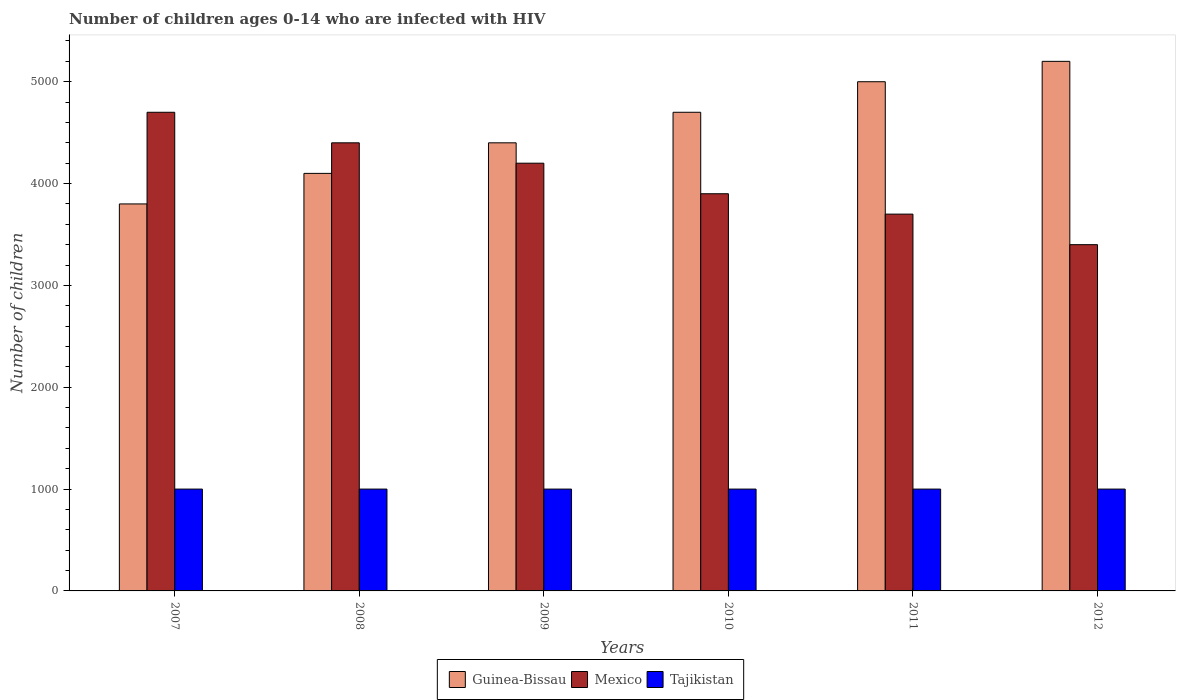How many bars are there on the 1st tick from the left?
Your answer should be compact. 3. How many bars are there on the 3rd tick from the right?
Keep it short and to the point. 3. What is the label of the 3rd group of bars from the left?
Your answer should be compact. 2009. In how many cases, is the number of bars for a given year not equal to the number of legend labels?
Offer a terse response. 0. What is the number of HIV infected children in Tajikistan in 2012?
Make the answer very short. 1000. Across all years, what is the maximum number of HIV infected children in Guinea-Bissau?
Your answer should be compact. 5200. Across all years, what is the minimum number of HIV infected children in Guinea-Bissau?
Provide a short and direct response. 3800. What is the total number of HIV infected children in Guinea-Bissau in the graph?
Your response must be concise. 2.72e+04. What is the difference between the number of HIV infected children in Tajikistan in 2007 and the number of HIV infected children in Mexico in 2009?
Your answer should be compact. -3200. What is the average number of HIV infected children in Tajikistan per year?
Offer a very short reply. 1000. In the year 2007, what is the difference between the number of HIV infected children in Mexico and number of HIV infected children in Guinea-Bissau?
Ensure brevity in your answer.  900. In how many years, is the number of HIV infected children in Mexico greater than 3200?
Offer a very short reply. 6. Is the number of HIV infected children in Mexico in 2008 less than that in 2011?
Your response must be concise. No. Is the difference between the number of HIV infected children in Mexico in 2008 and 2012 greater than the difference between the number of HIV infected children in Guinea-Bissau in 2008 and 2012?
Provide a succinct answer. Yes. What is the difference between the highest and the second highest number of HIV infected children in Mexico?
Make the answer very short. 300. What is the difference between the highest and the lowest number of HIV infected children in Mexico?
Give a very brief answer. 1300. In how many years, is the number of HIV infected children in Tajikistan greater than the average number of HIV infected children in Tajikistan taken over all years?
Your response must be concise. 0. What does the 3rd bar from the left in 2011 represents?
Give a very brief answer. Tajikistan. What does the 1st bar from the right in 2008 represents?
Your answer should be very brief. Tajikistan. How many years are there in the graph?
Provide a short and direct response. 6. What is the difference between two consecutive major ticks on the Y-axis?
Ensure brevity in your answer.  1000. Are the values on the major ticks of Y-axis written in scientific E-notation?
Your response must be concise. No. Does the graph contain grids?
Your answer should be compact. No. Where does the legend appear in the graph?
Your answer should be very brief. Bottom center. How many legend labels are there?
Offer a terse response. 3. How are the legend labels stacked?
Make the answer very short. Horizontal. What is the title of the graph?
Give a very brief answer. Number of children ages 0-14 who are infected with HIV. What is the label or title of the Y-axis?
Provide a succinct answer. Number of children. What is the Number of children in Guinea-Bissau in 2007?
Ensure brevity in your answer.  3800. What is the Number of children in Mexico in 2007?
Your answer should be very brief. 4700. What is the Number of children in Tajikistan in 2007?
Provide a short and direct response. 1000. What is the Number of children in Guinea-Bissau in 2008?
Your answer should be very brief. 4100. What is the Number of children in Mexico in 2008?
Offer a very short reply. 4400. What is the Number of children of Guinea-Bissau in 2009?
Your answer should be compact. 4400. What is the Number of children in Mexico in 2009?
Give a very brief answer. 4200. What is the Number of children of Guinea-Bissau in 2010?
Offer a terse response. 4700. What is the Number of children in Mexico in 2010?
Your response must be concise. 3900. What is the Number of children of Tajikistan in 2010?
Give a very brief answer. 1000. What is the Number of children in Mexico in 2011?
Your answer should be very brief. 3700. What is the Number of children of Tajikistan in 2011?
Your answer should be compact. 1000. What is the Number of children of Guinea-Bissau in 2012?
Ensure brevity in your answer.  5200. What is the Number of children of Mexico in 2012?
Offer a very short reply. 3400. What is the Number of children of Tajikistan in 2012?
Offer a very short reply. 1000. Across all years, what is the maximum Number of children in Guinea-Bissau?
Your response must be concise. 5200. Across all years, what is the maximum Number of children in Mexico?
Make the answer very short. 4700. Across all years, what is the minimum Number of children of Guinea-Bissau?
Offer a very short reply. 3800. Across all years, what is the minimum Number of children of Mexico?
Make the answer very short. 3400. What is the total Number of children in Guinea-Bissau in the graph?
Provide a succinct answer. 2.72e+04. What is the total Number of children of Mexico in the graph?
Ensure brevity in your answer.  2.43e+04. What is the total Number of children in Tajikistan in the graph?
Provide a short and direct response. 6000. What is the difference between the Number of children in Guinea-Bissau in 2007 and that in 2008?
Offer a terse response. -300. What is the difference between the Number of children in Mexico in 2007 and that in 2008?
Your response must be concise. 300. What is the difference between the Number of children in Tajikistan in 2007 and that in 2008?
Make the answer very short. 0. What is the difference between the Number of children in Guinea-Bissau in 2007 and that in 2009?
Offer a very short reply. -600. What is the difference between the Number of children of Tajikistan in 2007 and that in 2009?
Your answer should be compact. 0. What is the difference between the Number of children of Guinea-Bissau in 2007 and that in 2010?
Your response must be concise. -900. What is the difference between the Number of children of Mexico in 2007 and that in 2010?
Offer a very short reply. 800. What is the difference between the Number of children in Guinea-Bissau in 2007 and that in 2011?
Your answer should be compact. -1200. What is the difference between the Number of children of Mexico in 2007 and that in 2011?
Provide a succinct answer. 1000. What is the difference between the Number of children of Tajikistan in 2007 and that in 2011?
Provide a succinct answer. 0. What is the difference between the Number of children in Guinea-Bissau in 2007 and that in 2012?
Ensure brevity in your answer.  -1400. What is the difference between the Number of children of Mexico in 2007 and that in 2012?
Your response must be concise. 1300. What is the difference between the Number of children of Guinea-Bissau in 2008 and that in 2009?
Offer a very short reply. -300. What is the difference between the Number of children of Mexico in 2008 and that in 2009?
Offer a terse response. 200. What is the difference between the Number of children of Guinea-Bissau in 2008 and that in 2010?
Offer a terse response. -600. What is the difference between the Number of children in Mexico in 2008 and that in 2010?
Offer a terse response. 500. What is the difference between the Number of children in Guinea-Bissau in 2008 and that in 2011?
Provide a short and direct response. -900. What is the difference between the Number of children of Mexico in 2008 and that in 2011?
Your response must be concise. 700. What is the difference between the Number of children in Tajikistan in 2008 and that in 2011?
Ensure brevity in your answer.  0. What is the difference between the Number of children of Guinea-Bissau in 2008 and that in 2012?
Provide a short and direct response. -1100. What is the difference between the Number of children of Guinea-Bissau in 2009 and that in 2010?
Your answer should be compact. -300. What is the difference between the Number of children of Mexico in 2009 and that in 2010?
Your answer should be very brief. 300. What is the difference between the Number of children in Tajikistan in 2009 and that in 2010?
Keep it short and to the point. 0. What is the difference between the Number of children of Guinea-Bissau in 2009 and that in 2011?
Ensure brevity in your answer.  -600. What is the difference between the Number of children in Mexico in 2009 and that in 2011?
Make the answer very short. 500. What is the difference between the Number of children in Guinea-Bissau in 2009 and that in 2012?
Your response must be concise. -800. What is the difference between the Number of children of Mexico in 2009 and that in 2012?
Your response must be concise. 800. What is the difference between the Number of children of Guinea-Bissau in 2010 and that in 2011?
Give a very brief answer. -300. What is the difference between the Number of children in Tajikistan in 2010 and that in 2011?
Ensure brevity in your answer.  0. What is the difference between the Number of children in Guinea-Bissau in 2010 and that in 2012?
Keep it short and to the point. -500. What is the difference between the Number of children in Mexico in 2010 and that in 2012?
Give a very brief answer. 500. What is the difference between the Number of children in Tajikistan in 2010 and that in 2012?
Ensure brevity in your answer.  0. What is the difference between the Number of children in Guinea-Bissau in 2011 and that in 2012?
Offer a very short reply. -200. What is the difference between the Number of children of Mexico in 2011 and that in 2012?
Your answer should be very brief. 300. What is the difference between the Number of children in Guinea-Bissau in 2007 and the Number of children in Mexico in 2008?
Ensure brevity in your answer.  -600. What is the difference between the Number of children of Guinea-Bissau in 2007 and the Number of children of Tajikistan in 2008?
Ensure brevity in your answer.  2800. What is the difference between the Number of children in Mexico in 2007 and the Number of children in Tajikistan in 2008?
Provide a short and direct response. 3700. What is the difference between the Number of children in Guinea-Bissau in 2007 and the Number of children in Mexico in 2009?
Your response must be concise. -400. What is the difference between the Number of children in Guinea-Bissau in 2007 and the Number of children in Tajikistan in 2009?
Your answer should be compact. 2800. What is the difference between the Number of children of Mexico in 2007 and the Number of children of Tajikistan in 2009?
Your response must be concise. 3700. What is the difference between the Number of children of Guinea-Bissau in 2007 and the Number of children of Mexico in 2010?
Keep it short and to the point. -100. What is the difference between the Number of children of Guinea-Bissau in 2007 and the Number of children of Tajikistan in 2010?
Provide a short and direct response. 2800. What is the difference between the Number of children of Mexico in 2007 and the Number of children of Tajikistan in 2010?
Give a very brief answer. 3700. What is the difference between the Number of children in Guinea-Bissau in 2007 and the Number of children in Tajikistan in 2011?
Offer a very short reply. 2800. What is the difference between the Number of children of Mexico in 2007 and the Number of children of Tajikistan in 2011?
Provide a short and direct response. 3700. What is the difference between the Number of children of Guinea-Bissau in 2007 and the Number of children of Mexico in 2012?
Offer a terse response. 400. What is the difference between the Number of children in Guinea-Bissau in 2007 and the Number of children in Tajikistan in 2012?
Your answer should be very brief. 2800. What is the difference between the Number of children in Mexico in 2007 and the Number of children in Tajikistan in 2012?
Your answer should be very brief. 3700. What is the difference between the Number of children in Guinea-Bissau in 2008 and the Number of children in Mexico in 2009?
Make the answer very short. -100. What is the difference between the Number of children in Guinea-Bissau in 2008 and the Number of children in Tajikistan in 2009?
Your response must be concise. 3100. What is the difference between the Number of children in Mexico in 2008 and the Number of children in Tajikistan in 2009?
Provide a short and direct response. 3400. What is the difference between the Number of children in Guinea-Bissau in 2008 and the Number of children in Mexico in 2010?
Offer a terse response. 200. What is the difference between the Number of children of Guinea-Bissau in 2008 and the Number of children of Tajikistan in 2010?
Make the answer very short. 3100. What is the difference between the Number of children of Mexico in 2008 and the Number of children of Tajikistan in 2010?
Offer a very short reply. 3400. What is the difference between the Number of children in Guinea-Bissau in 2008 and the Number of children in Mexico in 2011?
Ensure brevity in your answer.  400. What is the difference between the Number of children of Guinea-Bissau in 2008 and the Number of children of Tajikistan in 2011?
Your answer should be very brief. 3100. What is the difference between the Number of children of Mexico in 2008 and the Number of children of Tajikistan in 2011?
Offer a terse response. 3400. What is the difference between the Number of children in Guinea-Bissau in 2008 and the Number of children in Mexico in 2012?
Provide a short and direct response. 700. What is the difference between the Number of children in Guinea-Bissau in 2008 and the Number of children in Tajikistan in 2012?
Your response must be concise. 3100. What is the difference between the Number of children in Mexico in 2008 and the Number of children in Tajikistan in 2012?
Provide a succinct answer. 3400. What is the difference between the Number of children of Guinea-Bissau in 2009 and the Number of children of Mexico in 2010?
Provide a short and direct response. 500. What is the difference between the Number of children of Guinea-Bissau in 2009 and the Number of children of Tajikistan in 2010?
Provide a succinct answer. 3400. What is the difference between the Number of children of Mexico in 2009 and the Number of children of Tajikistan in 2010?
Provide a short and direct response. 3200. What is the difference between the Number of children of Guinea-Bissau in 2009 and the Number of children of Mexico in 2011?
Provide a short and direct response. 700. What is the difference between the Number of children in Guinea-Bissau in 2009 and the Number of children in Tajikistan in 2011?
Give a very brief answer. 3400. What is the difference between the Number of children of Mexico in 2009 and the Number of children of Tajikistan in 2011?
Your answer should be very brief. 3200. What is the difference between the Number of children of Guinea-Bissau in 2009 and the Number of children of Mexico in 2012?
Make the answer very short. 1000. What is the difference between the Number of children of Guinea-Bissau in 2009 and the Number of children of Tajikistan in 2012?
Keep it short and to the point. 3400. What is the difference between the Number of children of Mexico in 2009 and the Number of children of Tajikistan in 2012?
Give a very brief answer. 3200. What is the difference between the Number of children of Guinea-Bissau in 2010 and the Number of children of Tajikistan in 2011?
Offer a very short reply. 3700. What is the difference between the Number of children in Mexico in 2010 and the Number of children in Tajikistan in 2011?
Your answer should be compact. 2900. What is the difference between the Number of children of Guinea-Bissau in 2010 and the Number of children of Mexico in 2012?
Offer a very short reply. 1300. What is the difference between the Number of children in Guinea-Bissau in 2010 and the Number of children in Tajikistan in 2012?
Give a very brief answer. 3700. What is the difference between the Number of children in Mexico in 2010 and the Number of children in Tajikistan in 2012?
Your answer should be compact. 2900. What is the difference between the Number of children in Guinea-Bissau in 2011 and the Number of children in Mexico in 2012?
Provide a succinct answer. 1600. What is the difference between the Number of children in Guinea-Bissau in 2011 and the Number of children in Tajikistan in 2012?
Your answer should be very brief. 4000. What is the difference between the Number of children of Mexico in 2011 and the Number of children of Tajikistan in 2012?
Make the answer very short. 2700. What is the average Number of children of Guinea-Bissau per year?
Offer a very short reply. 4533.33. What is the average Number of children of Mexico per year?
Offer a very short reply. 4050. In the year 2007, what is the difference between the Number of children of Guinea-Bissau and Number of children of Mexico?
Your answer should be compact. -900. In the year 2007, what is the difference between the Number of children of Guinea-Bissau and Number of children of Tajikistan?
Provide a succinct answer. 2800. In the year 2007, what is the difference between the Number of children of Mexico and Number of children of Tajikistan?
Provide a short and direct response. 3700. In the year 2008, what is the difference between the Number of children in Guinea-Bissau and Number of children in Mexico?
Make the answer very short. -300. In the year 2008, what is the difference between the Number of children of Guinea-Bissau and Number of children of Tajikistan?
Ensure brevity in your answer.  3100. In the year 2008, what is the difference between the Number of children of Mexico and Number of children of Tajikistan?
Ensure brevity in your answer.  3400. In the year 2009, what is the difference between the Number of children in Guinea-Bissau and Number of children in Mexico?
Offer a very short reply. 200. In the year 2009, what is the difference between the Number of children in Guinea-Bissau and Number of children in Tajikistan?
Ensure brevity in your answer.  3400. In the year 2009, what is the difference between the Number of children in Mexico and Number of children in Tajikistan?
Ensure brevity in your answer.  3200. In the year 2010, what is the difference between the Number of children in Guinea-Bissau and Number of children in Mexico?
Ensure brevity in your answer.  800. In the year 2010, what is the difference between the Number of children of Guinea-Bissau and Number of children of Tajikistan?
Provide a succinct answer. 3700. In the year 2010, what is the difference between the Number of children in Mexico and Number of children in Tajikistan?
Make the answer very short. 2900. In the year 2011, what is the difference between the Number of children in Guinea-Bissau and Number of children in Mexico?
Provide a succinct answer. 1300. In the year 2011, what is the difference between the Number of children in Guinea-Bissau and Number of children in Tajikistan?
Offer a very short reply. 4000. In the year 2011, what is the difference between the Number of children of Mexico and Number of children of Tajikistan?
Keep it short and to the point. 2700. In the year 2012, what is the difference between the Number of children in Guinea-Bissau and Number of children in Mexico?
Give a very brief answer. 1800. In the year 2012, what is the difference between the Number of children of Guinea-Bissau and Number of children of Tajikistan?
Offer a terse response. 4200. In the year 2012, what is the difference between the Number of children of Mexico and Number of children of Tajikistan?
Your answer should be very brief. 2400. What is the ratio of the Number of children of Guinea-Bissau in 2007 to that in 2008?
Ensure brevity in your answer.  0.93. What is the ratio of the Number of children of Mexico in 2007 to that in 2008?
Your response must be concise. 1.07. What is the ratio of the Number of children of Guinea-Bissau in 2007 to that in 2009?
Your answer should be very brief. 0.86. What is the ratio of the Number of children of Mexico in 2007 to that in 2009?
Provide a short and direct response. 1.12. What is the ratio of the Number of children in Tajikistan in 2007 to that in 2009?
Keep it short and to the point. 1. What is the ratio of the Number of children of Guinea-Bissau in 2007 to that in 2010?
Provide a short and direct response. 0.81. What is the ratio of the Number of children of Mexico in 2007 to that in 2010?
Your response must be concise. 1.21. What is the ratio of the Number of children of Tajikistan in 2007 to that in 2010?
Provide a succinct answer. 1. What is the ratio of the Number of children in Guinea-Bissau in 2007 to that in 2011?
Keep it short and to the point. 0.76. What is the ratio of the Number of children in Mexico in 2007 to that in 2011?
Your answer should be compact. 1.27. What is the ratio of the Number of children in Tajikistan in 2007 to that in 2011?
Your response must be concise. 1. What is the ratio of the Number of children in Guinea-Bissau in 2007 to that in 2012?
Your answer should be very brief. 0.73. What is the ratio of the Number of children of Mexico in 2007 to that in 2012?
Your answer should be very brief. 1.38. What is the ratio of the Number of children in Guinea-Bissau in 2008 to that in 2009?
Make the answer very short. 0.93. What is the ratio of the Number of children of Mexico in 2008 to that in 2009?
Provide a succinct answer. 1.05. What is the ratio of the Number of children in Tajikistan in 2008 to that in 2009?
Ensure brevity in your answer.  1. What is the ratio of the Number of children in Guinea-Bissau in 2008 to that in 2010?
Provide a short and direct response. 0.87. What is the ratio of the Number of children of Mexico in 2008 to that in 2010?
Your response must be concise. 1.13. What is the ratio of the Number of children of Tajikistan in 2008 to that in 2010?
Provide a short and direct response. 1. What is the ratio of the Number of children of Guinea-Bissau in 2008 to that in 2011?
Make the answer very short. 0.82. What is the ratio of the Number of children in Mexico in 2008 to that in 2011?
Give a very brief answer. 1.19. What is the ratio of the Number of children of Tajikistan in 2008 to that in 2011?
Ensure brevity in your answer.  1. What is the ratio of the Number of children in Guinea-Bissau in 2008 to that in 2012?
Provide a short and direct response. 0.79. What is the ratio of the Number of children of Mexico in 2008 to that in 2012?
Keep it short and to the point. 1.29. What is the ratio of the Number of children in Tajikistan in 2008 to that in 2012?
Your answer should be compact. 1. What is the ratio of the Number of children of Guinea-Bissau in 2009 to that in 2010?
Offer a very short reply. 0.94. What is the ratio of the Number of children in Tajikistan in 2009 to that in 2010?
Provide a short and direct response. 1. What is the ratio of the Number of children in Guinea-Bissau in 2009 to that in 2011?
Make the answer very short. 0.88. What is the ratio of the Number of children of Mexico in 2009 to that in 2011?
Your answer should be very brief. 1.14. What is the ratio of the Number of children in Guinea-Bissau in 2009 to that in 2012?
Give a very brief answer. 0.85. What is the ratio of the Number of children in Mexico in 2009 to that in 2012?
Provide a succinct answer. 1.24. What is the ratio of the Number of children in Mexico in 2010 to that in 2011?
Offer a very short reply. 1.05. What is the ratio of the Number of children of Tajikistan in 2010 to that in 2011?
Provide a succinct answer. 1. What is the ratio of the Number of children in Guinea-Bissau in 2010 to that in 2012?
Make the answer very short. 0.9. What is the ratio of the Number of children of Mexico in 2010 to that in 2012?
Offer a terse response. 1.15. What is the ratio of the Number of children of Guinea-Bissau in 2011 to that in 2012?
Provide a succinct answer. 0.96. What is the ratio of the Number of children of Mexico in 2011 to that in 2012?
Provide a short and direct response. 1.09. What is the ratio of the Number of children in Tajikistan in 2011 to that in 2012?
Offer a very short reply. 1. What is the difference between the highest and the second highest Number of children of Guinea-Bissau?
Make the answer very short. 200. What is the difference between the highest and the second highest Number of children in Mexico?
Ensure brevity in your answer.  300. What is the difference between the highest and the second highest Number of children in Tajikistan?
Offer a very short reply. 0. What is the difference between the highest and the lowest Number of children of Guinea-Bissau?
Your answer should be compact. 1400. What is the difference between the highest and the lowest Number of children of Mexico?
Offer a very short reply. 1300. 